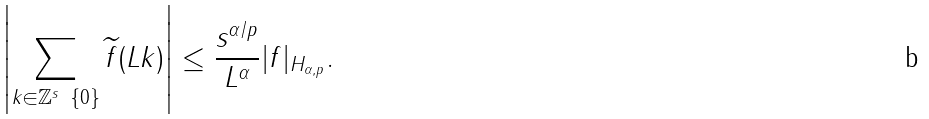<formula> <loc_0><loc_0><loc_500><loc_500>\left | \sum _ { k \in \mathbb { Z } ^ { s } \ \{ 0 \} } \widetilde { f } ( L k ) \right | \leq \frac { s ^ { \alpha / p } } { L ^ { \alpha } } | f | _ { H _ { \alpha , p } } .</formula> 